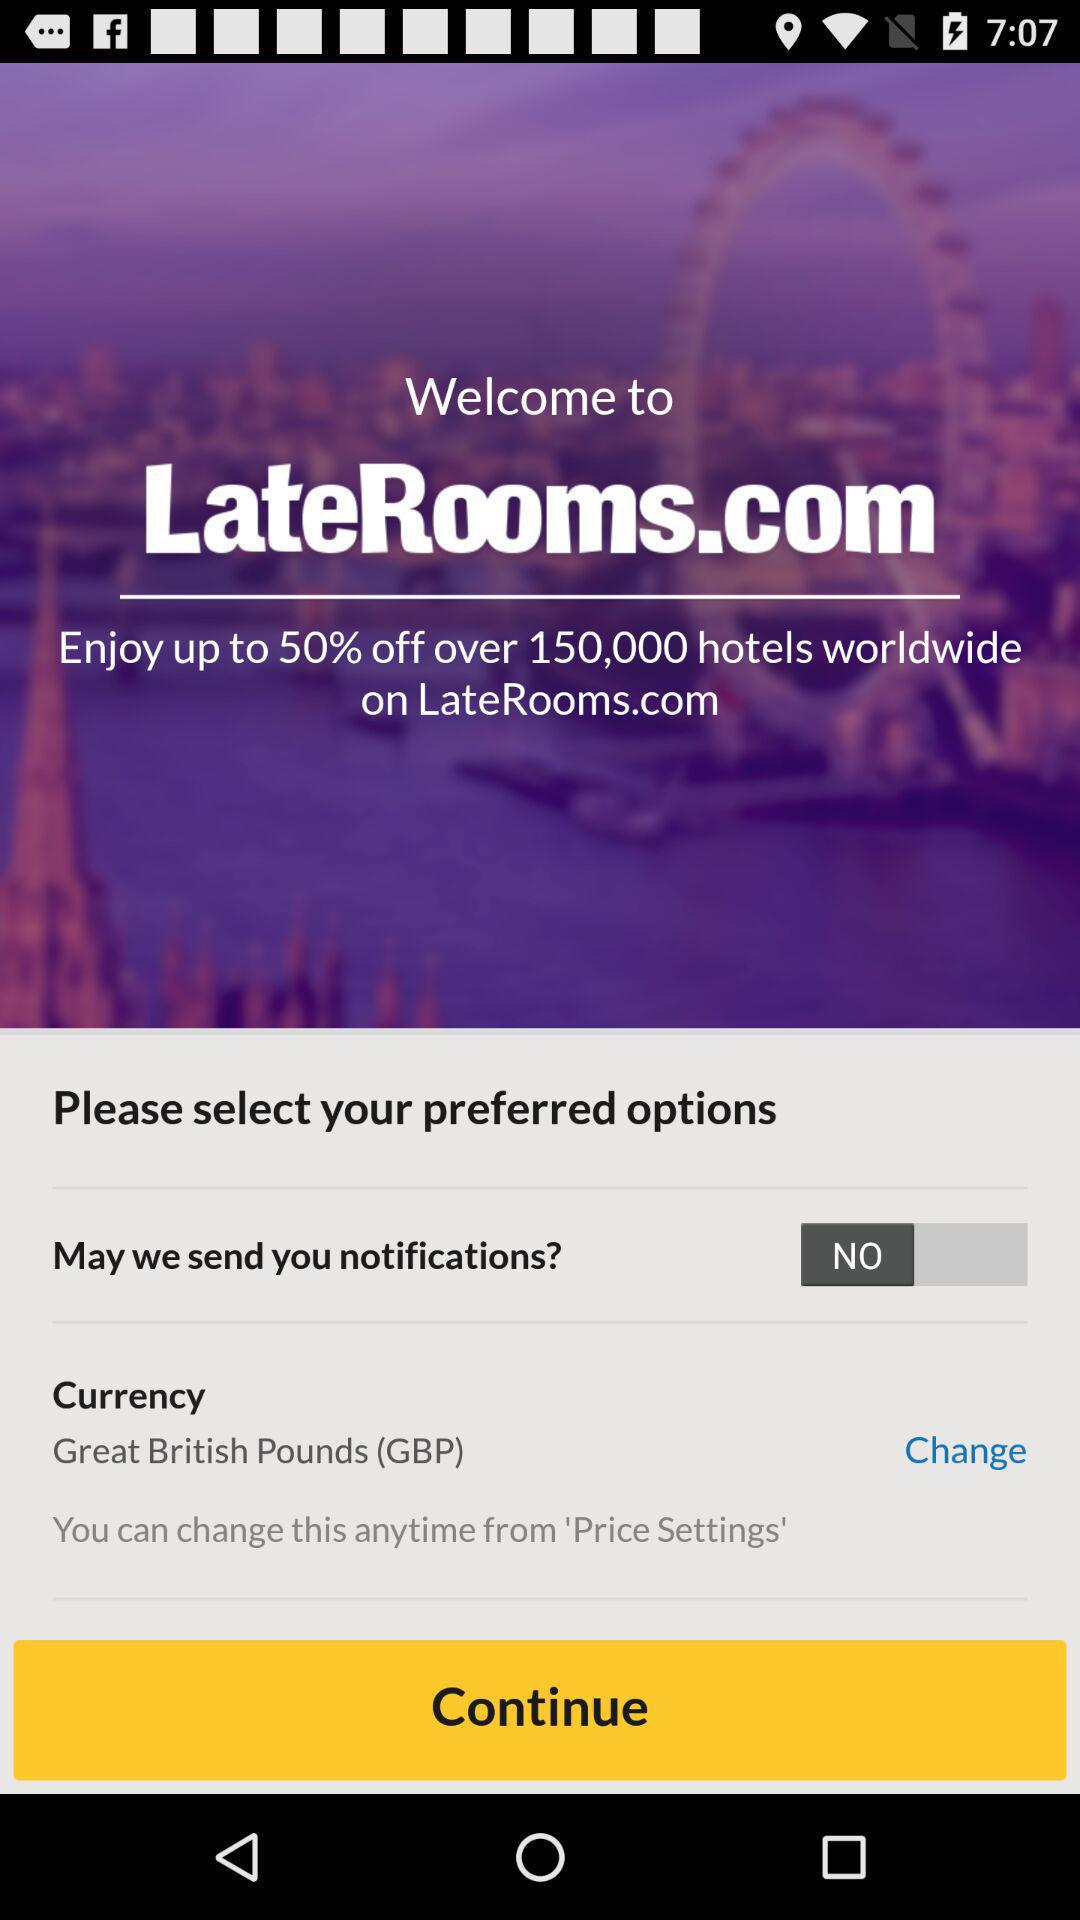What is the application name? The application name is "LateRooms". 